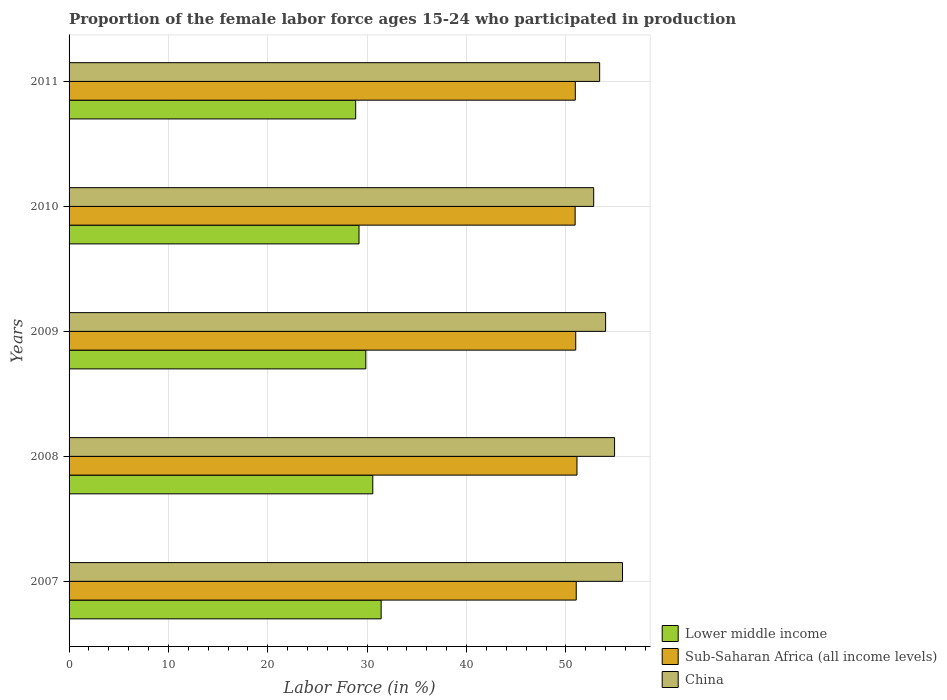Are the number of bars per tick equal to the number of legend labels?
Make the answer very short. Yes. Are the number of bars on each tick of the Y-axis equal?
Make the answer very short. Yes. What is the proportion of the female labor force who participated in production in Sub-Saharan Africa (all income levels) in 2008?
Provide a short and direct response. 51.12. Across all years, what is the maximum proportion of the female labor force who participated in production in Lower middle income?
Your answer should be very brief. 31.41. Across all years, what is the minimum proportion of the female labor force who participated in production in China?
Provide a succinct answer. 52.8. In which year was the proportion of the female labor force who participated in production in Sub-Saharan Africa (all income levels) maximum?
Keep it short and to the point. 2008. What is the total proportion of the female labor force who participated in production in Sub-Saharan Africa (all income levels) in the graph?
Offer a very short reply. 255.04. What is the difference between the proportion of the female labor force who participated in production in China in 2007 and that in 2009?
Offer a very short reply. 1.7. What is the difference between the proportion of the female labor force who participated in production in Sub-Saharan Africa (all income levels) in 2009 and the proportion of the female labor force who participated in production in China in 2008?
Your answer should be compact. -3.91. What is the average proportion of the female labor force who participated in production in Sub-Saharan Africa (all income levels) per year?
Offer a terse response. 51.01. In the year 2010, what is the difference between the proportion of the female labor force who participated in production in China and proportion of the female labor force who participated in production in Lower middle income?
Provide a short and direct response. 23.62. What is the ratio of the proportion of the female labor force who participated in production in China in 2008 to that in 2010?
Ensure brevity in your answer.  1.04. What is the difference between the highest and the second highest proportion of the female labor force who participated in production in Lower middle income?
Ensure brevity in your answer.  0.84. What is the difference between the highest and the lowest proportion of the female labor force who participated in production in Sub-Saharan Africa (all income levels)?
Your answer should be compact. 0.19. What does the 3rd bar from the top in 2007 represents?
Offer a terse response. Lower middle income. What does the 2nd bar from the bottom in 2007 represents?
Give a very brief answer. Sub-Saharan Africa (all income levels). Is it the case that in every year, the sum of the proportion of the female labor force who participated in production in Sub-Saharan Africa (all income levels) and proportion of the female labor force who participated in production in China is greater than the proportion of the female labor force who participated in production in Lower middle income?
Keep it short and to the point. Yes. How many bars are there?
Ensure brevity in your answer.  15. Are all the bars in the graph horizontal?
Your answer should be very brief. Yes. How many years are there in the graph?
Your response must be concise. 5. What is the difference between two consecutive major ticks on the X-axis?
Make the answer very short. 10. Does the graph contain any zero values?
Your answer should be very brief. No. How many legend labels are there?
Give a very brief answer. 3. What is the title of the graph?
Provide a succinct answer. Proportion of the female labor force ages 15-24 who participated in production. What is the label or title of the Y-axis?
Your response must be concise. Years. What is the Labor Force (in %) of Lower middle income in 2007?
Your answer should be very brief. 31.41. What is the Labor Force (in %) of Sub-Saharan Africa (all income levels) in 2007?
Your answer should be very brief. 51.04. What is the Labor Force (in %) in China in 2007?
Offer a terse response. 55.7. What is the Labor Force (in %) of Lower middle income in 2008?
Make the answer very short. 30.57. What is the Labor Force (in %) in Sub-Saharan Africa (all income levels) in 2008?
Your answer should be very brief. 51.12. What is the Labor Force (in %) of China in 2008?
Offer a very short reply. 54.9. What is the Labor Force (in %) of Lower middle income in 2009?
Provide a short and direct response. 29.86. What is the Labor Force (in %) in Sub-Saharan Africa (all income levels) in 2009?
Keep it short and to the point. 50.99. What is the Labor Force (in %) in China in 2009?
Give a very brief answer. 54. What is the Labor Force (in %) in Lower middle income in 2010?
Provide a short and direct response. 29.18. What is the Labor Force (in %) in Sub-Saharan Africa (all income levels) in 2010?
Keep it short and to the point. 50.93. What is the Labor Force (in %) in China in 2010?
Keep it short and to the point. 52.8. What is the Labor Force (in %) in Lower middle income in 2011?
Offer a terse response. 28.85. What is the Labor Force (in %) of Sub-Saharan Africa (all income levels) in 2011?
Offer a terse response. 50.95. What is the Labor Force (in %) of China in 2011?
Your answer should be very brief. 53.4. Across all years, what is the maximum Labor Force (in %) in Lower middle income?
Keep it short and to the point. 31.41. Across all years, what is the maximum Labor Force (in %) in Sub-Saharan Africa (all income levels)?
Keep it short and to the point. 51.12. Across all years, what is the maximum Labor Force (in %) of China?
Offer a terse response. 55.7. Across all years, what is the minimum Labor Force (in %) of Lower middle income?
Keep it short and to the point. 28.85. Across all years, what is the minimum Labor Force (in %) of Sub-Saharan Africa (all income levels)?
Offer a very short reply. 50.93. Across all years, what is the minimum Labor Force (in %) in China?
Provide a succinct answer. 52.8. What is the total Labor Force (in %) in Lower middle income in the graph?
Provide a short and direct response. 149.87. What is the total Labor Force (in %) in Sub-Saharan Africa (all income levels) in the graph?
Your response must be concise. 255.04. What is the total Labor Force (in %) of China in the graph?
Offer a very short reply. 270.8. What is the difference between the Labor Force (in %) in Lower middle income in 2007 and that in 2008?
Your answer should be compact. 0.84. What is the difference between the Labor Force (in %) of Sub-Saharan Africa (all income levels) in 2007 and that in 2008?
Provide a short and direct response. -0.08. What is the difference between the Labor Force (in %) of Lower middle income in 2007 and that in 2009?
Your answer should be very brief. 1.54. What is the difference between the Labor Force (in %) in Sub-Saharan Africa (all income levels) in 2007 and that in 2009?
Make the answer very short. 0.05. What is the difference between the Labor Force (in %) of China in 2007 and that in 2009?
Offer a terse response. 1.7. What is the difference between the Labor Force (in %) of Lower middle income in 2007 and that in 2010?
Your answer should be very brief. 2.23. What is the difference between the Labor Force (in %) of Sub-Saharan Africa (all income levels) in 2007 and that in 2010?
Make the answer very short. 0.11. What is the difference between the Labor Force (in %) of Lower middle income in 2007 and that in 2011?
Ensure brevity in your answer.  2.56. What is the difference between the Labor Force (in %) of Sub-Saharan Africa (all income levels) in 2007 and that in 2011?
Offer a very short reply. 0.09. What is the difference between the Labor Force (in %) of China in 2007 and that in 2011?
Make the answer very short. 2.3. What is the difference between the Labor Force (in %) of Lower middle income in 2008 and that in 2009?
Give a very brief answer. 0.7. What is the difference between the Labor Force (in %) in Sub-Saharan Africa (all income levels) in 2008 and that in 2009?
Make the answer very short. 0.13. What is the difference between the Labor Force (in %) in China in 2008 and that in 2009?
Provide a succinct answer. 0.9. What is the difference between the Labor Force (in %) in Lower middle income in 2008 and that in 2010?
Offer a terse response. 1.39. What is the difference between the Labor Force (in %) of Sub-Saharan Africa (all income levels) in 2008 and that in 2010?
Give a very brief answer. 0.19. What is the difference between the Labor Force (in %) of China in 2008 and that in 2010?
Ensure brevity in your answer.  2.1. What is the difference between the Labor Force (in %) of Lower middle income in 2008 and that in 2011?
Offer a very short reply. 1.72. What is the difference between the Labor Force (in %) of Sub-Saharan Africa (all income levels) in 2008 and that in 2011?
Provide a short and direct response. 0.17. What is the difference between the Labor Force (in %) in China in 2008 and that in 2011?
Provide a succinct answer. 1.5. What is the difference between the Labor Force (in %) of Lower middle income in 2009 and that in 2010?
Your response must be concise. 0.68. What is the difference between the Labor Force (in %) of Sub-Saharan Africa (all income levels) in 2009 and that in 2010?
Give a very brief answer. 0.06. What is the difference between the Labor Force (in %) in China in 2009 and that in 2010?
Your answer should be very brief. 1.2. What is the difference between the Labor Force (in %) of Lower middle income in 2009 and that in 2011?
Keep it short and to the point. 1.02. What is the difference between the Labor Force (in %) of Sub-Saharan Africa (all income levels) in 2009 and that in 2011?
Offer a terse response. 0.04. What is the difference between the Labor Force (in %) of China in 2009 and that in 2011?
Keep it short and to the point. 0.6. What is the difference between the Labor Force (in %) of Lower middle income in 2010 and that in 2011?
Your answer should be very brief. 0.34. What is the difference between the Labor Force (in %) in Sub-Saharan Africa (all income levels) in 2010 and that in 2011?
Provide a succinct answer. -0.02. What is the difference between the Labor Force (in %) in Lower middle income in 2007 and the Labor Force (in %) in Sub-Saharan Africa (all income levels) in 2008?
Provide a short and direct response. -19.71. What is the difference between the Labor Force (in %) in Lower middle income in 2007 and the Labor Force (in %) in China in 2008?
Provide a short and direct response. -23.49. What is the difference between the Labor Force (in %) in Sub-Saharan Africa (all income levels) in 2007 and the Labor Force (in %) in China in 2008?
Provide a succinct answer. -3.86. What is the difference between the Labor Force (in %) of Lower middle income in 2007 and the Labor Force (in %) of Sub-Saharan Africa (all income levels) in 2009?
Your response must be concise. -19.59. What is the difference between the Labor Force (in %) of Lower middle income in 2007 and the Labor Force (in %) of China in 2009?
Offer a terse response. -22.59. What is the difference between the Labor Force (in %) of Sub-Saharan Africa (all income levels) in 2007 and the Labor Force (in %) of China in 2009?
Provide a short and direct response. -2.96. What is the difference between the Labor Force (in %) of Lower middle income in 2007 and the Labor Force (in %) of Sub-Saharan Africa (all income levels) in 2010?
Your answer should be very brief. -19.53. What is the difference between the Labor Force (in %) in Lower middle income in 2007 and the Labor Force (in %) in China in 2010?
Give a very brief answer. -21.39. What is the difference between the Labor Force (in %) in Sub-Saharan Africa (all income levels) in 2007 and the Labor Force (in %) in China in 2010?
Give a very brief answer. -1.76. What is the difference between the Labor Force (in %) in Lower middle income in 2007 and the Labor Force (in %) in Sub-Saharan Africa (all income levels) in 2011?
Give a very brief answer. -19.54. What is the difference between the Labor Force (in %) in Lower middle income in 2007 and the Labor Force (in %) in China in 2011?
Provide a short and direct response. -21.99. What is the difference between the Labor Force (in %) of Sub-Saharan Africa (all income levels) in 2007 and the Labor Force (in %) of China in 2011?
Provide a short and direct response. -2.36. What is the difference between the Labor Force (in %) in Lower middle income in 2008 and the Labor Force (in %) in Sub-Saharan Africa (all income levels) in 2009?
Provide a succinct answer. -20.42. What is the difference between the Labor Force (in %) in Lower middle income in 2008 and the Labor Force (in %) in China in 2009?
Provide a succinct answer. -23.43. What is the difference between the Labor Force (in %) of Sub-Saharan Africa (all income levels) in 2008 and the Labor Force (in %) of China in 2009?
Offer a terse response. -2.88. What is the difference between the Labor Force (in %) in Lower middle income in 2008 and the Labor Force (in %) in Sub-Saharan Africa (all income levels) in 2010?
Give a very brief answer. -20.37. What is the difference between the Labor Force (in %) of Lower middle income in 2008 and the Labor Force (in %) of China in 2010?
Provide a short and direct response. -22.23. What is the difference between the Labor Force (in %) of Sub-Saharan Africa (all income levels) in 2008 and the Labor Force (in %) of China in 2010?
Your answer should be very brief. -1.68. What is the difference between the Labor Force (in %) in Lower middle income in 2008 and the Labor Force (in %) in Sub-Saharan Africa (all income levels) in 2011?
Your answer should be very brief. -20.38. What is the difference between the Labor Force (in %) in Lower middle income in 2008 and the Labor Force (in %) in China in 2011?
Your answer should be compact. -22.83. What is the difference between the Labor Force (in %) in Sub-Saharan Africa (all income levels) in 2008 and the Labor Force (in %) in China in 2011?
Offer a very short reply. -2.28. What is the difference between the Labor Force (in %) of Lower middle income in 2009 and the Labor Force (in %) of Sub-Saharan Africa (all income levels) in 2010?
Offer a terse response. -21.07. What is the difference between the Labor Force (in %) in Lower middle income in 2009 and the Labor Force (in %) in China in 2010?
Offer a very short reply. -22.93. What is the difference between the Labor Force (in %) in Sub-Saharan Africa (all income levels) in 2009 and the Labor Force (in %) in China in 2010?
Provide a short and direct response. -1.81. What is the difference between the Labor Force (in %) in Lower middle income in 2009 and the Labor Force (in %) in Sub-Saharan Africa (all income levels) in 2011?
Your answer should be very brief. -21.09. What is the difference between the Labor Force (in %) in Lower middle income in 2009 and the Labor Force (in %) in China in 2011?
Offer a very short reply. -23.54. What is the difference between the Labor Force (in %) in Sub-Saharan Africa (all income levels) in 2009 and the Labor Force (in %) in China in 2011?
Give a very brief answer. -2.41. What is the difference between the Labor Force (in %) in Lower middle income in 2010 and the Labor Force (in %) in Sub-Saharan Africa (all income levels) in 2011?
Provide a succinct answer. -21.77. What is the difference between the Labor Force (in %) of Lower middle income in 2010 and the Labor Force (in %) of China in 2011?
Give a very brief answer. -24.22. What is the difference between the Labor Force (in %) of Sub-Saharan Africa (all income levels) in 2010 and the Labor Force (in %) of China in 2011?
Your answer should be compact. -2.47. What is the average Labor Force (in %) in Lower middle income per year?
Give a very brief answer. 29.97. What is the average Labor Force (in %) of Sub-Saharan Africa (all income levels) per year?
Provide a succinct answer. 51.01. What is the average Labor Force (in %) in China per year?
Ensure brevity in your answer.  54.16. In the year 2007, what is the difference between the Labor Force (in %) of Lower middle income and Labor Force (in %) of Sub-Saharan Africa (all income levels)?
Make the answer very short. -19.64. In the year 2007, what is the difference between the Labor Force (in %) of Lower middle income and Labor Force (in %) of China?
Make the answer very short. -24.29. In the year 2007, what is the difference between the Labor Force (in %) of Sub-Saharan Africa (all income levels) and Labor Force (in %) of China?
Your response must be concise. -4.66. In the year 2008, what is the difference between the Labor Force (in %) in Lower middle income and Labor Force (in %) in Sub-Saharan Africa (all income levels)?
Make the answer very short. -20.55. In the year 2008, what is the difference between the Labor Force (in %) in Lower middle income and Labor Force (in %) in China?
Your response must be concise. -24.33. In the year 2008, what is the difference between the Labor Force (in %) in Sub-Saharan Africa (all income levels) and Labor Force (in %) in China?
Give a very brief answer. -3.78. In the year 2009, what is the difference between the Labor Force (in %) in Lower middle income and Labor Force (in %) in Sub-Saharan Africa (all income levels)?
Give a very brief answer. -21.13. In the year 2009, what is the difference between the Labor Force (in %) of Lower middle income and Labor Force (in %) of China?
Your answer should be very brief. -24.14. In the year 2009, what is the difference between the Labor Force (in %) of Sub-Saharan Africa (all income levels) and Labor Force (in %) of China?
Your response must be concise. -3.01. In the year 2010, what is the difference between the Labor Force (in %) in Lower middle income and Labor Force (in %) in Sub-Saharan Africa (all income levels)?
Give a very brief answer. -21.75. In the year 2010, what is the difference between the Labor Force (in %) of Lower middle income and Labor Force (in %) of China?
Make the answer very short. -23.62. In the year 2010, what is the difference between the Labor Force (in %) in Sub-Saharan Africa (all income levels) and Labor Force (in %) in China?
Ensure brevity in your answer.  -1.87. In the year 2011, what is the difference between the Labor Force (in %) of Lower middle income and Labor Force (in %) of Sub-Saharan Africa (all income levels)?
Your answer should be compact. -22.11. In the year 2011, what is the difference between the Labor Force (in %) of Lower middle income and Labor Force (in %) of China?
Offer a very short reply. -24.55. In the year 2011, what is the difference between the Labor Force (in %) in Sub-Saharan Africa (all income levels) and Labor Force (in %) in China?
Your answer should be compact. -2.45. What is the ratio of the Labor Force (in %) of Lower middle income in 2007 to that in 2008?
Keep it short and to the point. 1.03. What is the ratio of the Labor Force (in %) in Sub-Saharan Africa (all income levels) in 2007 to that in 2008?
Provide a short and direct response. 1. What is the ratio of the Labor Force (in %) in China in 2007 to that in 2008?
Your answer should be compact. 1.01. What is the ratio of the Labor Force (in %) of Lower middle income in 2007 to that in 2009?
Keep it short and to the point. 1.05. What is the ratio of the Labor Force (in %) of Sub-Saharan Africa (all income levels) in 2007 to that in 2009?
Ensure brevity in your answer.  1. What is the ratio of the Labor Force (in %) in China in 2007 to that in 2009?
Make the answer very short. 1.03. What is the ratio of the Labor Force (in %) in Lower middle income in 2007 to that in 2010?
Your response must be concise. 1.08. What is the ratio of the Labor Force (in %) in Sub-Saharan Africa (all income levels) in 2007 to that in 2010?
Provide a succinct answer. 1. What is the ratio of the Labor Force (in %) of China in 2007 to that in 2010?
Keep it short and to the point. 1.05. What is the ratio of the Labor Force (in %) of Lower middle income in 2007 to that in 2011?
Your answer should be compact. 1.09. What is the ratio of the Labor Force (in %) of China in 2007 to that in 2011?
Offer a very short reply. 1.04. What is the ratio of the Labor Force (in %) of Lower middle income in 2008 to that in 2009?
Your answer should be very brief. 1.02. What is the ratio of the Labor Force (in %) in China in 2008 to that in 2009?
Your answer should be very brief. 1.02. What is the ratio of the Labor Force (in %) of Lower middle income in 2008 to that in 2010?
Your answer should be compact. 1.05. What is the ratio of the Labor Force (in %) of Sub-Saharan Africa (all income levels) in 2008 to that in 2010?
Give a very brief answer. 1. What is the ratio of the Labor Force (in %) of China in 2008 to that in 2010?
Make the answer very short. 1.04. What is the ratio of the Labor Force (in %) of Lower middle income in 2008 to that in 2011?
Offer a very short reply. 1.06. What is the ratio of the Labor Force (in %) in Sub-Saharan Africa (all income levels) in 2008 to that in 2011?
Offer a terse response. 1. What is the ratio of the Labor Force (in %) in China in 2008 to that in 2011?
Your answer should be very brief. 1.03. What is the ratio of the Labor Force (in %) in Lower middle income in 2009 to that in 2010?
Offer a very short reply. 1.02. What is the ratio of the Labor Force (in %) of China in 2009 to that in 2010?
Make the answer very short. 1.02. What is the ratio of the Labor Force (in %) of Lower middle income in 2009 to that in 2011?
Your response must be concise. 1.04. What is the ratio of the Labor Force (in %) of Sub-Saharan Africa (all income levels) in 2009 to that in 2011?
Provide a succinct answer. 1. What is the ratio of the Labor Force (in %) in China in 2009 to that in 2011?
Provide a short and direct response. 1.01. What is the ratio of the Labor Force (in %) of Lower middle income in 2010 to that in 2011?
Your response must be concise. 1.01. What is the ratio of the Labor Force (in %) in Sub-Saharan Africa (all income levels) in 2010 to that in 2011?
Provide a succinct answer. 1. What is the difference between the highest and the second highest Labor Force (in %) of Lower middle income?
Keep it short and to the point. 0.84. What is the difference between the highest and the second highest Labor Force (in %) of Sub-Saharan Africa (all income levels)?
Offer a very short reply. 0.08. What is the difference between the highest and the lowest Labor Force (in %) of Lower middle income?
Your response must be concise. 2.56. What is the difference between the highest and the lowest Labor Force (in %) of Sub-Saharan Africa (all income levels)?
Provide a short and direct response. 0.19. 